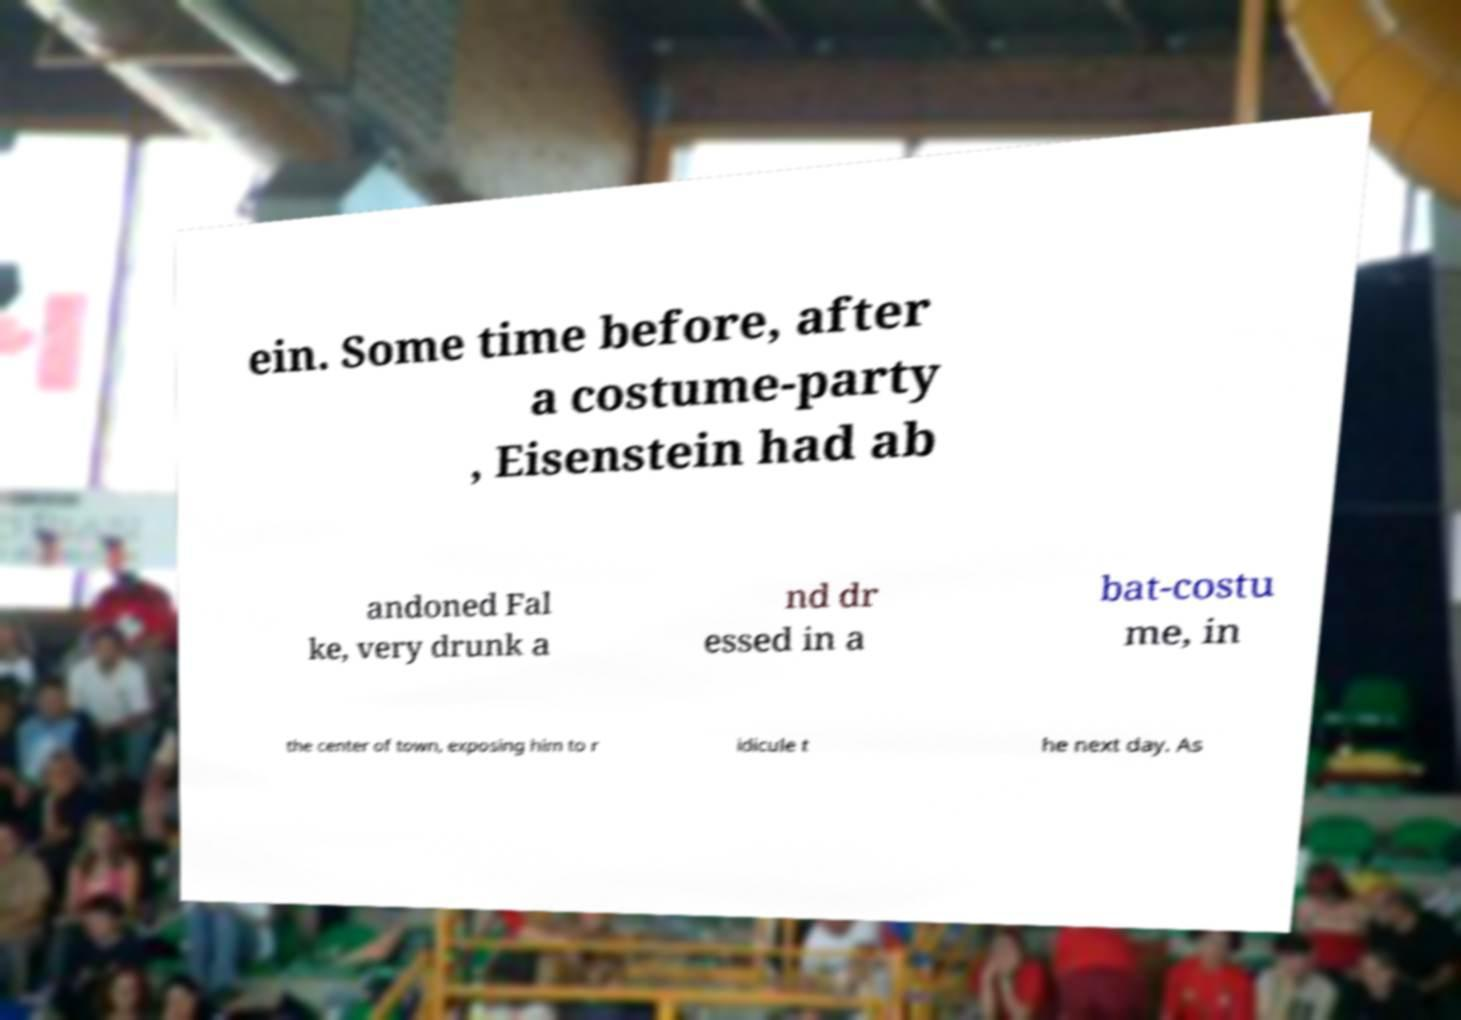Can you read and provide the text displayed in the image?This photo seems to have some interesting text. Can you extract and type it out for me? ein. Some time before, after a costume-party , Eisenstein had ab andoned Fal ke, very drunk a nd dr essed in a bat-costu me, in the center of town, exposing him to r idicule t he next day. As 